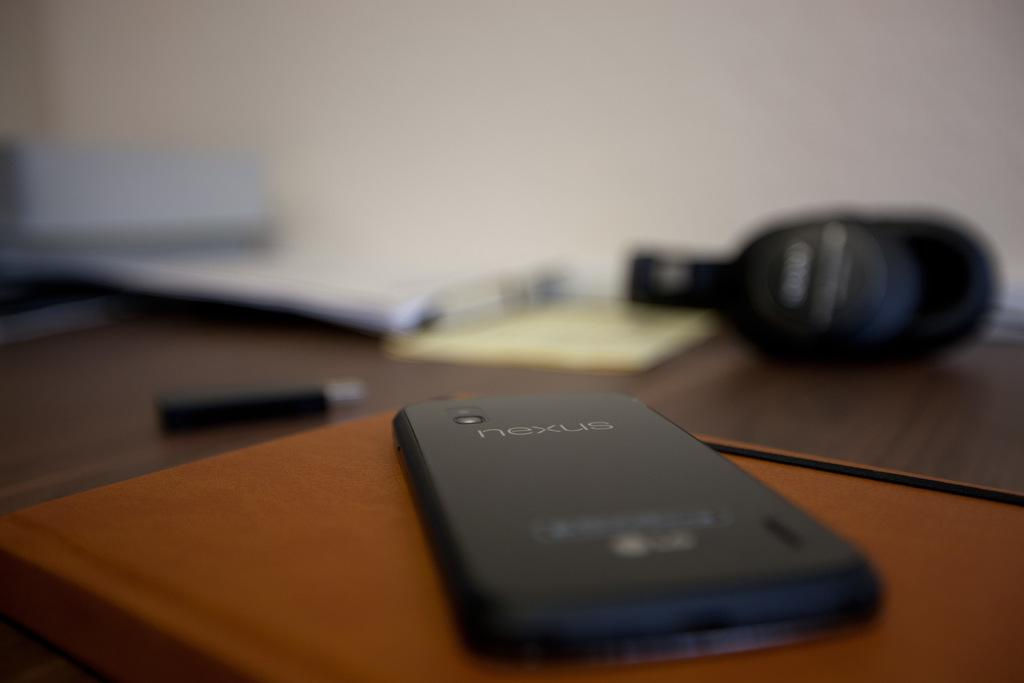<image>
Provide a brief description of the given image. A nexus phone laying face down on a table. 